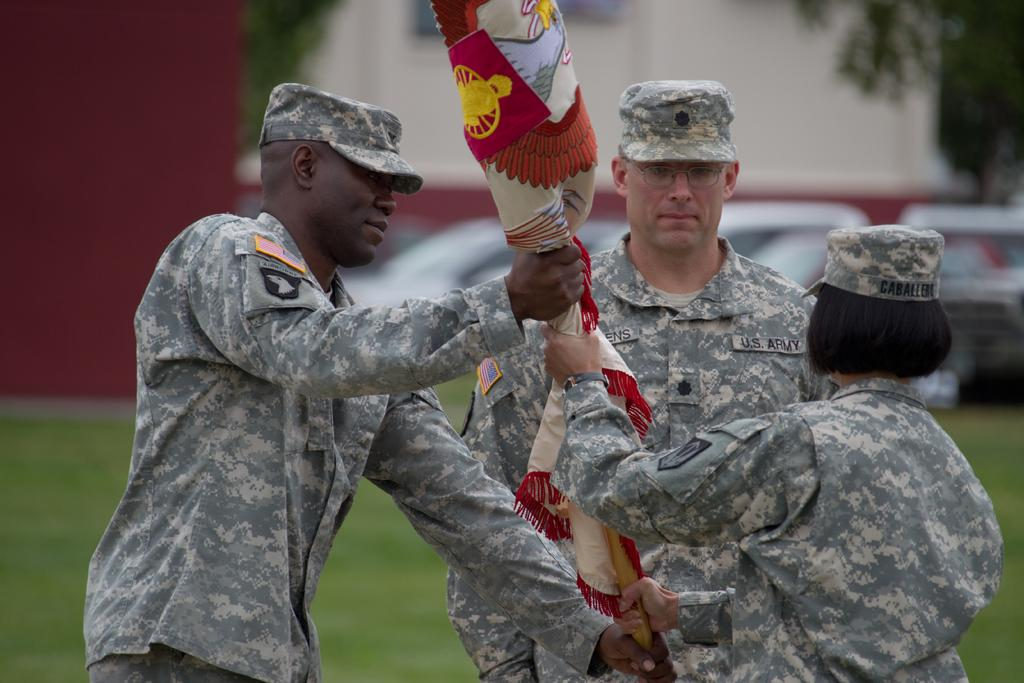How many people are in the image? There are 3 people in the image. What are the people doing in the image? The people are standing and holding a flag. What are the people wearing on their heads? The people are wearing caps. What type of clothing are the people wearing? The people are wearing uniforms. Can you describe the background of the image? The background of the image is blurred. What type of cork can be seen in the image? There is no cork present in the image. Can you tell me how many bikes are visible in the image? There are no bikes visible in the image. 